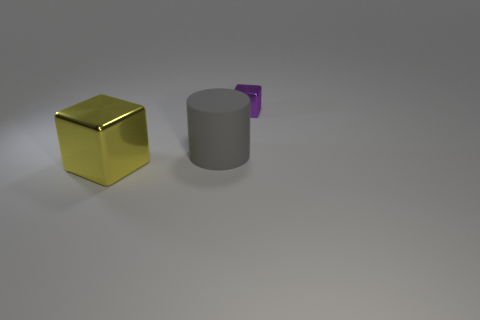Subtract all gray blocks. Subtract all yellow spheres. How many blocks are left? 2 Add 3 matte cylinders. How many objects exist? 6 Subtract all cubes. How many objects are left? 1 Add 3 big gray cylinders. How many big gray cylinders are left? 4 Add 1 matte things. How many matte things exist? 2 Subtract 0 red spheres. How many objects are left? 3 Subtract all matte cylinders. Subtract all gray cylinders. How many objects are left? 1 